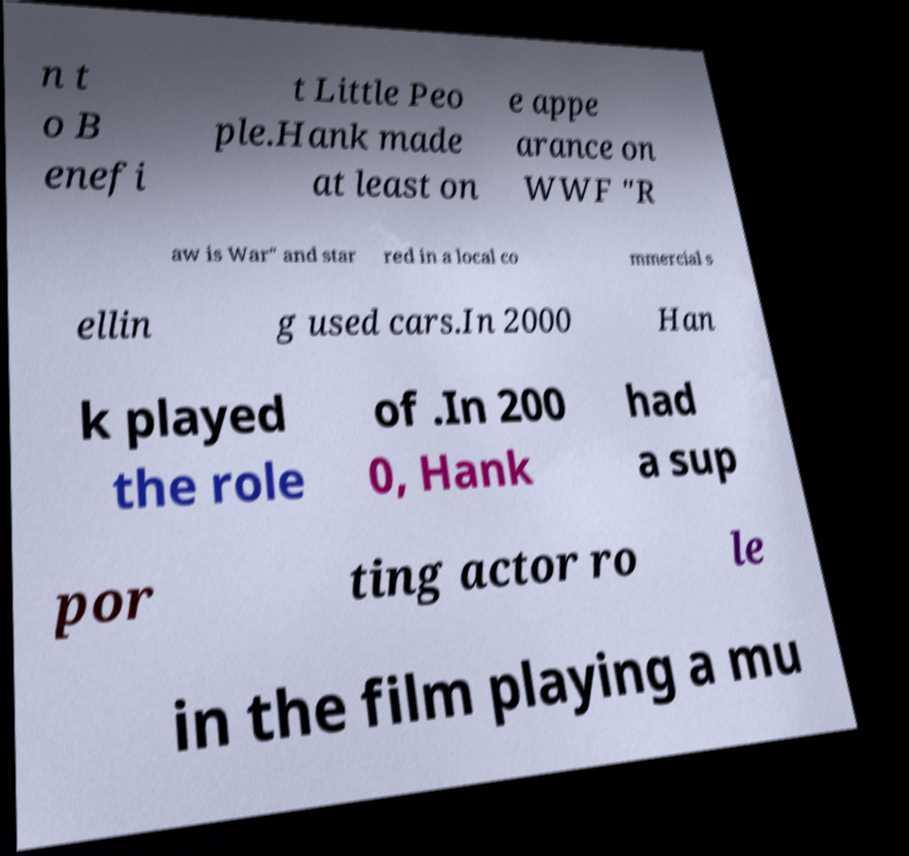For documentation purposes, I need the text within this image transcribed. Could you provide that? n t o B enefi t Little Peo ple.Hank made at least on e appe arance on WWF "R aw is War" and star red in a local co mmercial s ellin g used cars.In 2000 Han k played the role of .In 200 0, Hank had a sup por ting actor ro le in the film playing a mu 